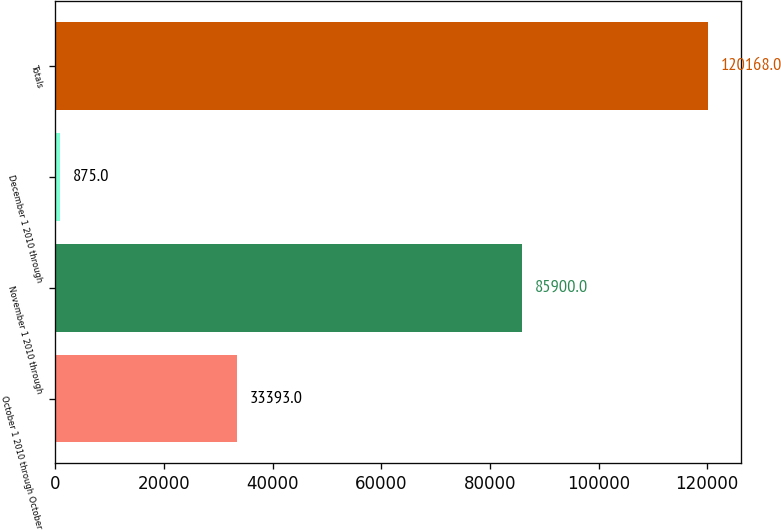Convert chart. <chart><loc_0><loc_0><loc_500><loc_500><bar_chart><fcel>October 1 2010 through October<fcel>November 1 2010 through<fcel>December 1 2010 through<fcel>Totals<nl><fcel>33393<fcel>85900<fcel>875<fcel>120168<nl></chart> 